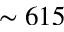<formula> <loc_0><loc_0><loc_500><loc_500>\sim 6 1 5</formula> 